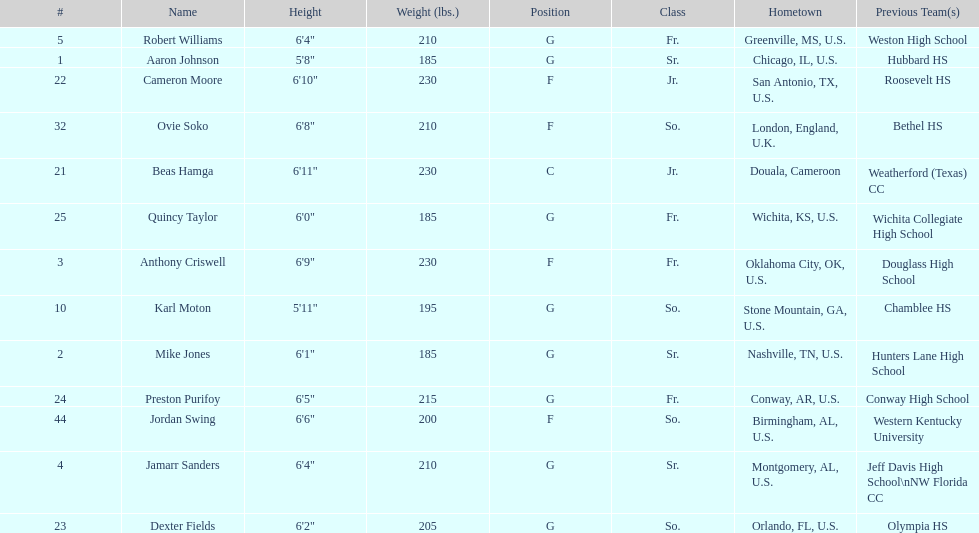Who has a greater weight, dexter fields or ovie soko? Ovie Soko. 